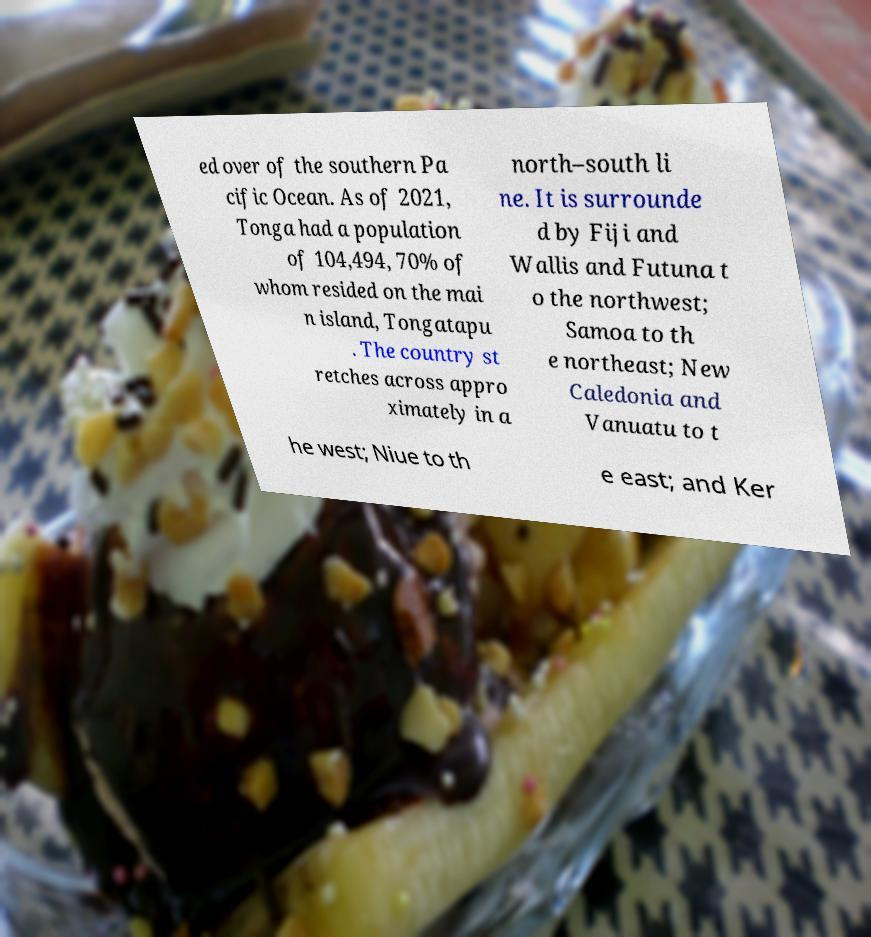Can you read and provide the text displayed in the image?This photo seems to have some interesting text. Can you extract and type it out for me? ed over of the southern Pa cific Ocean. As of 2021, Tonga had a population of 104,494, 70% of whom resided on the mai n island, Tongatapu . The country st retches across appro ximately in a north–south li ne. It is surrounde d by Fiji and Wallis and Futuna t o the northwest; Samoa to th e northeast; New Caledonia and Vanuatu to t he west; Niue to th e east; and Ker 